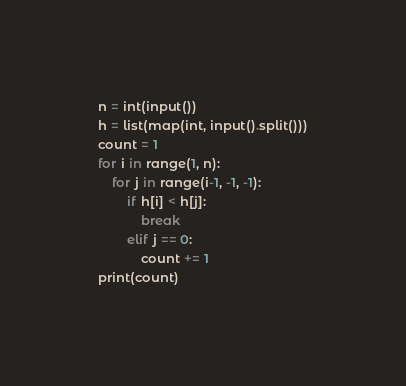Convert code to text. <code><loc_0><loc_0><loc_500><loc_500><_Python_>n = int(input())
h = list(map(int, input().split()))
count = 1
for i in range(1, n):
    for j in range(i-1, -1, -1):
        if h[i] < h[j]:
            break
        elif j == 0:
            count += 1
print(count)</code> 